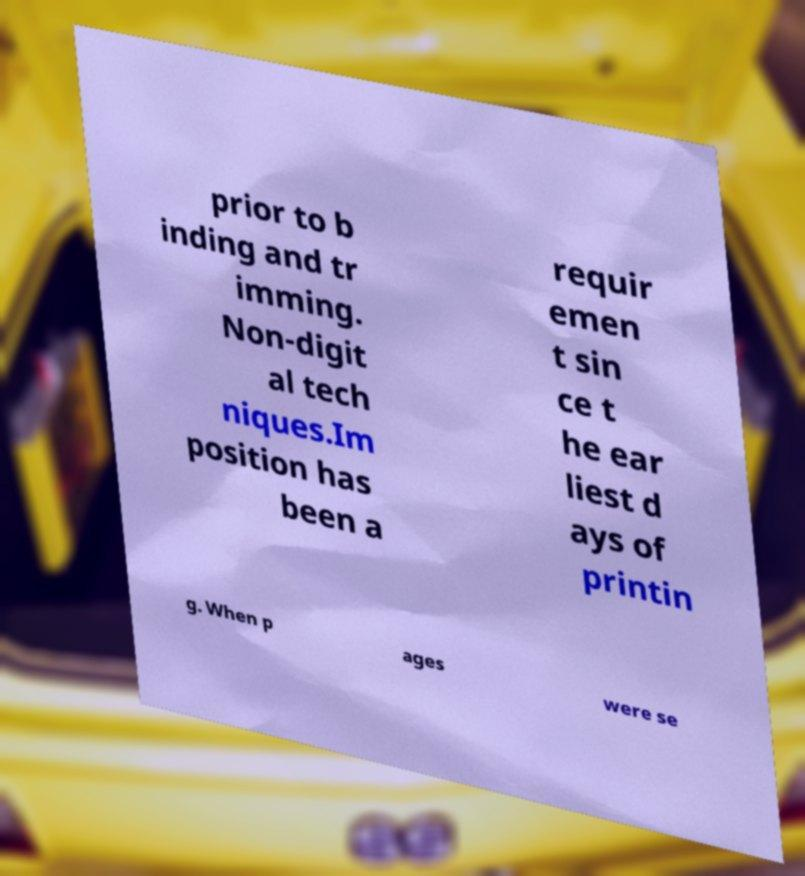I need the written content from this picture converted into text. Can you do that? prior to b inding and tr imming. Non-digit al tech niques.Im position has been a requir emen t sin ce t he ear liest d ays of printin g. When p ages were se 